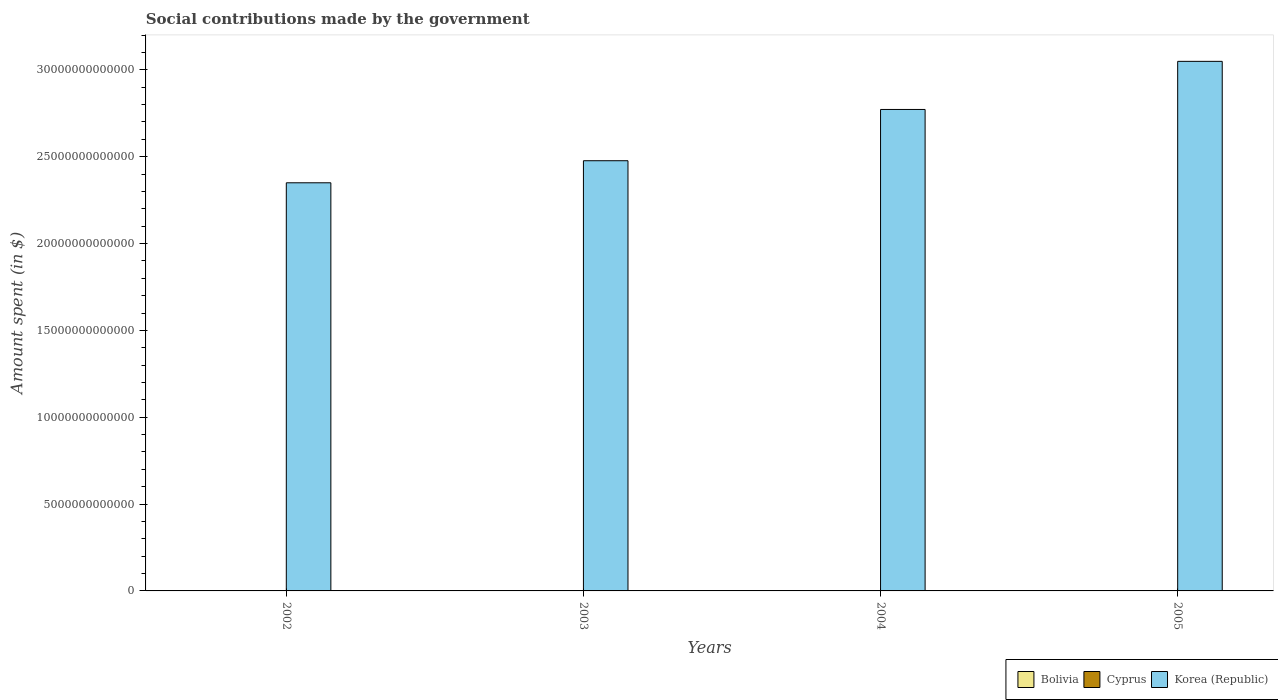How many different coloured bars are there?
Provide a short and direct response. 3. Are the number of bars per tick equal to the number of legend labels?
Keep it short and to the point. Yes. How many bars are there on the 4th tick from the right?
Your response must be concise. 3. What is the label of the 1st group of bars from the left?
Make the answer very short. 2002. What is the amount spent on social contributions in Cyprus in 2002?
Ensure brevity in your answer.  1.26e+09. Across all years, what is the maximum amount spent on social contributions in Bolivia?
Offer a terse response. 1.52e+09. Across all years, what is the minimum amount spent on social contributions in Cyprus?
Offer a terse response. 1.26e+09. In which year was the amount spent on social contributions in Cyprus maximum?
Ensure brevity in your answer.  2005. In which year was the amount spent on social contributions in Korea (Republic) minimum?
Provide a short and direct response. 2002. What is the total amount spent on social contributions in Cyprus in the graph?
Make the answer very short. 6.22e+09. What is the difference between the amount spent on social contributions in Korea (Republic) in 2002 and that in 2004?
Keep it short and to the point. -4.22e+12. What is the difference between the amount spent on social contributions in Cyprus in 2005 and the amount spent on social contributions in Korea (Republic) in 2002?
Give a very brief answer. -2.35e+13. What is the average amount spent on social contributions in Korea (Republic) per year?
Keep it short and to the point. 2.66e+13. In the year 2003, what is the difference between the amount spent on social contributions in Bolivia and amount spent on social contributions in Cyprus?
Your answer should be compact. 2.79e+07. In how many years, is the amount spent on social contributions in Cyprus greater than 10000000000000 $?
Ensure brevity in your answer.  0. What is the ratio of the amount spent on social contributions in Cyprus in 2002 to that in 2004?
Provide a short and direct response. 0.76. Is the difference between the amount spent on social contributions in Bolivia in 2002 and 2004 greater than the difference between the amount spent on social contributions in Cyprus in 2002 and 2004?
Offer a very short reply. Yes. What is the difference between the highest and the second highest amount spent on social contributions in Bolivia?
Give a very brief answer. 9.23e+07. What is the difference between the highest and the lowest amount spent on social contributions in Bolivia?
Ensure brevity in your answer.  4.39e+08. What does the 3rd bar from the left in 2005 represents?
Ensure brevity in your answer.  Korea (Republic). What does the 2nd bar from the right in 2002 represents?
Your answer should be very brief. Cyprus. How many bars are there?
Your answer should be compact. 12. Are all the bars in the graph horizontal?
Provide a succinct answer. No. How many years are there in the graph?
Offer a terse response. 4. What is the difference between two consecutive major ticks on the Y-axis?
Give a very brief answer. 5.00e+12. Are the values on the major ticks of Y-axis written in scientific E-notation?
Your answer should be very brief. No. Does the graph contain grids?
Offer a terse response. No. Where does the legend appear in the graph?
Give a very brief answer. Bottom right. How many legend labels are there?
Offer a very short reply. 3. How are the legend labels stacked?
Ensure brevity in your answer.  Horizontal. What is the title of the graph?
Your answer should be very brief. Social contributions made by the government. Does "Rwanda" appear as one of the legend labels in the graph?
Offer a terse response. No. What is the label or title of the Y-axis?
Ensure brevity in your answer.  Amount spent (in $). What is the Amount spent (in $) of Bolivia in 2002?
Provide a short and direct response. 1.08e+09. What is the Amount spent (in $) in Cyprus in 2002?
Offer a very short reply. 1.26e+09. What is the Amount spent (in $) of Korea (Republic) in 2002?
Offer a terse response. 2.35e+13. What is the Amount spent (in $) of Bolivia in 2003?
Offer a very short reply. 1.43e+09. What is the Amount spent (in $) in Cyprus in 2003?
Your answer should be very brief. 1.40e+09. What is the Amount spent (in $) of Korea (Republic) in 2003?
Provide a succinct answer. 2.48e+13. What is the Amount spent (in $) of Bolivia in 2004?
Your answer should be very brief. 1.34e+09. What is the Amount spent (in $) in Cyprus in 2004?
Provide a short and direct response. 1.66e+09. What is the Amount spent (in $) of Korea (Republic) in 2004?
Give a very brief answer. 2.77e+13. What is the Amount spent (in $) in Bolivia in 2005?
Offer a terse response. 1.52e+09. What is the Amount spent (in $) of Cyprus in 2005?
Your answer should be compact. 1.90e+09. What is the Amount spent (in $) in Korea (Republic) in 2005?
Your response must be concise. 3.05e+13. Across all years, what is the maximum Amount spent (in $) in Bolivia?
Ensure brevity in your answer.  1.52e+09. Across all years, what is the maximum Amount spent (in $) in Cyprus?
Provide a succinct answer. 1.90e+09. Across all years, what is the maximum Amount spent (in $) in Korea (Republic)?
Your answer should be very brief. 3.05e+13. Across all years, what is the minimum Amount spent (in $) of Bolivia?
Offer a terse response. 1.08e+09. Across all years, what is the minimum Amount spent (in $) of Cyprus?
Provide a succinct answer. 1.26e+09. Across all years, what is the minimum Amount spent (in $) of Korea (Republic)?
Your answer should be compact. 2.35e+13. What is the total Amount spent (in $) of Bolivia in the graph?
Provide a short and direct response. 5.38e+09. What is the total Amount spent (in $) of Cyprus in the graph?
Ensure brevity in your answer.  6.22e+09. What is the total Amount spent (in $) in Korea (Republic) in the graph?
Ensure brevity in your answer.  1.06e+14. What is the difference between the Amount spent (in $) in Bolivia in 2002 and that in 2003?
Make the answer very short. -3.46e+08. What is the difference between the Amount spent (in $) of Cyprus in 2002 and that in 2003?
Give a very brief answer. -1.46e+08. What is the difference between the Amount spent (in $) of Korea (Republic) in 2002 and that in 2003?
Your response must be concise. -1.27e+12. What is the difference between the Amount spent (in $) of Bolivia in 2002 and that in 2004?
Provide a succinct answer. -2.54e+08. What is the difference between the Amount spent (in $) in Cyprus in 2002 and that in 2004?
Offer a terse response. -4.04e+08. What is the difference between the Amount spent (in $) of Korea (Republic) in 2002 and that in 2004?
Ensure brevity in your answer.  -4.22e+12. What is the difference between the Amount spent (in $) in Bolivia in 2002 and that in 2005?
Keep it short and to the point. -4.39e+08. What is the difference between the Amount spent (in $) of Cyprus in 2002 and that in 2005?
Offer a terse response. -6.40e+08. What is the difference between the Amount spent (in $) of Korea (Republic) in 2002 and that in 2005?
Ensure brevity in your answer.  -6.99e+12. What is the difference between the Amount spent (in $) of Bolivia in 2003 and that in 2004?
Provide a succinct answer. 9.22e+07. What is the difference between the Amount spent (in $) in Cyprus in 2003 and that in 2004?
Provide a succinct answer. -2.59e+08. What is the difference between the Amount spent (in $) of Korea (Republic) in 2003 and that in 2004?
Provide a succinct answer. -2.95e+12. What is the difference between the Amount spent (in $) of Bolivia in 2003 and that in 2005?
Offer a very short reply. -9.23e+07. What is the difference between the Amount spent (in $) of Cyprus in 2003 and that in 2005?
Your answer should be compact. -4.95e+08. What is the difference between the Amount spent (in $) in Korea (Republic) in 2003 and that in 2005?
Your answer should be very brief. -5.72e+12. What is the difference between the Amount spent (in $) in Bolivia in 2004 and that in 2005?
Provide a short and direct response. -1.84e+08. What is the difference between the Amount spent (in $) of Cyprus in 2004 and that in 2005?
Your answer should be very brief. -2.36e+08. What is the difference between the Amount spent (in $) of Korea (Republic) in 2004 and that in 2005?
Give a very brief answer. -2.77e+12. What is the difference between the Amount spent (in $) in Bolivia in 2002 and the Amount spent (in $) in Cyprus in 2003?
Your answer should be compact. -3.18e+08. What is the difference between the Amount spent (in $) of Bolivia in 2002 and the Amount spent (in $) of Korea (Republic) in 2003?
Offer a terse response. -2.48e+13. What is the difference between the Amount spent (in $) in Cyprus in 2002 and the Amount spent (in $) in Korea (Republic) in 2003?
Ensure brevity in your answer.  -2.48e+13. What is the difference between the Amount spent (in $) of Bolivia in 2002 and the Amount spent (in $) of Cyprus in 2004?
Offer a terse response. -5.77e+08. What is the difference between the Amount spent (in $) in Bolivia in 2002 and the Amount spent (in $) in Korea (Republic) in 2004?
Give a very brief answer. -2.77e+13. What is the difference between the Amount spent (in $) of Cyprus in 2002 and the Amount spent (in $) of Korea (Republic) in 2004?
Offer a very short reply. -2.77e+13. What is the difference between the Amount spent (in $) in Bolivia in 2002 and the Amount spent (in $) in Cyprus in 2005?
Offer a very short reply. -8.13e+08. What is the difference between the Amount spent (in $) in Bolivia in 2002 and the Amount spent (in $) in Korea (Republic) in 2005?
Offer a very short reply. -3.05e+13. What is the difference between the Amount spent (in $) of Cyprus in 2002 and the Amount spent (in $) of Korea (Republic) in 2005?
Ensure brevity in your answer.  -3.05e+13. What is the difference between the Amount spent (in $) in Bolivia in 2003 and the Amount spent (in $) in Cyprus in 2004?
Your answer should be compact. -2.31e+08. What is the difference between the Amount spent (in $) of Bolivia in 2003 and the Amount spent (in $) of Korea (Republic) in 2004?
Your answer should be very brief. -2.77e+13. What is the difference between the Amount spent (in $) of Cyprus in 2003 and the Amount spent (in $) of Korea (Republic) in 2004?
Provide a short and direct response. -2.77e+13. What is the difference between the Amount spent (in $) in Bolivia in 2003 and the Amount spent (in $) in Cyprus in 2005?
Your answer should be very brief. -4.67e+08. What is the difference between the Amount spent (in $) in Bolivia in 2003 and the Amount spent (in $) in Korea (Republic) in 2005?
Your answer should be compact. -3.05e+13. What is the difference between the Amount spent (in $) in Cyprus in 2003 and the Amount spent (in $) in Korea (Republic) in 2005?
Offer a terse response. -3.05e+13. What is the difference between the Amount spent (in $) in Bolivia in 2004 and the Amount spent (in $) in Cyprus in 2005?
Ensure brevity in your answer.  -5.59e+08. What is the difference between the Amount spent (in $) of Bolivia in 2004 and the Amount spent (in $) of Korea (Republic) in 2005?
Provide a short and direct response. -3.05e+13. What is the difference between the Amount spent (in $) of Cyprus in 2004 and the Amount spent (in $) of Korea (Republic) in 2005?
Make the answer very short. -3.05e+13. What is the average Amount spent (in $) in Bolivia per year?
Ensure brevity in your answer.  1.34e+09. What is the average Amount spent (in $) in Cyprus per year?
Ensure brevity in your answer.  1.55e+09. What is the average Amount spent (in $) of Korea (Republic) per year?
Provide a short and direct response. 2.66e+13. In the year 2002, what is the difference between the Amount spent (in $) in Bolivia and Amount spent (in $) in Cyprus?
Provide a succinct answer. -1.73e+08. In the year 2002, what is the difference between the Amount spent (in $) in Bolivia and Amount spent (in $) in Korea (Republic)?
Keep it short and to the point. -2.35e+13. In the year 2002, what is the difference between the Amount spent (in $) of Cyprus and Amount spent (in $) of Korea (Republic)?
Provide a short and direct response. -2.35e+13. In the year 2003, what is the difference between the Amount spent (in $) of Bolivia and Amount spent (in $) of Cyprus?
Offer a very short reply. 2.79e+07. In the year 2003, what is the difference between the Amount spent (in $) of Bolivia and Amount spent (in $) of Korea (Republic)?
Your answer should be very brief. -2.48e+13. In the year 2003, what is the difference between the Amount spent (in $) in Cyprus and Amount spent (in $) in Korea (Republic)?
Ensure brevity in your answer.  -2.48e+13. In the year 2004, what is the difference between the Amount spent (in $) of Bolivia and Amount spent (in $) of Cyprus?
Your response must be concise. -3.23e+08. In the year 2004, what is the difference between the Amount spent (in $) in Bolivia and Amount spent (in $) in Korea (Republic)?
Provide a succinct answer. -2.77e+13. In the year 2004, what is the difference between the Amount spent (in $) in Cyprus and Amount spent (in $) in Korea (Republic)?
Keep it short and to the point. -2.77e+13. In the year 2005, what is the difference between the Amount spent (in $) in Bolivia and Amount spent (in $) in Cyprus?
Offer a terse response. -3.75e+08. In the year 2005, what is the difference between the Amount spent (in $) in Bolivia and Amount spent (in $) in Korea (Republic)?
Offer a terse response. -3.05e+13. In the year 2005, what is the difference between the Amount spent (in $) in Cyprus and Amount spent (in $) in Korea (Republic)?
Make the answer very short. -3.05e+13. What is the ratio of the Amount spent (in $) in Bolivia in 2002 to that in 2003?
Offer a very short reply. 0.76. What is the ratio of the Amount spent (in $) of Cyprus in 2002 to that in 2003?
Offer a very short reply. 0.9. What is the ratio of the Amount spent (in $) in Korea (Republic) in 2002 to that in 2003?
Your answer should be very brief. 0.95. What is the ratio of the Amount spent (in $) in Bolivia in 2002 to that in 2004?
Provide a short and direct response. 0.81. What is the ratio of the Amount spent (in $) of Cyprus in 2002 to that in 2004?
Provide a succinct answer. 0.76. What is the ratio of the Amount spent (in $) of Korea (Republic) in 2002 to that in 2004?
Your answer should be very brief. 0.85. What is the ratio of the Amount spent (in $) in Bolivia in 2002 to that in 2005?
Provide a short and direct response. 0.71. What is the ratio of the Amount spent (in $) in Cyprus in 2002 to that in 2005?
Provide a short and direct response. 0.66. What is the ratio of the Amount spent (in $) in Korea (Republic) in 2002 to that in 2005?
Make the answer very short. 0.77. What is the ratio of the Amount spent (in $) of Bolivia in 2003 to that in 2004?
Offer a terse response. 1.07. What is the ratio of the Amount spent (in $) of Cyprus in 2003 to that in 2004?
Your response must be concise. 0.84. What is the ratio of the Amount spent (in $) of Korea (Republic) in 2003 to that in 2004?
Offer a terse response. 0.89. What is the ratio of the Amount spent (in $) of Bolivia in 2003 to that in 2005?
Your response must be concise. 0.94. What is the ratio of the Amount spent (in $) of Cyprus in 2003 to that in 2005?
Your answer should be compact. 0.74. What is the ratio of the Amount spent (in $) of Korea (Republic) in 2003 to that in 2005?
Offer a very short reply. 0.81. What is the ratio of the Amount spent (in $) of Bolivia in 2004 to that in 2005?
Make the answer very short. 0.88. What is the ratio of the Amount spent (in $) in Cyprus in 2004 to that in 2005?
Make the answer very short. 0.88. What is the ratio of the Amount spent (in $) of Korea (Republic) in 2004 to that in 2005?
Make the answer very short. 0.91. What is the difference between the highest and the second highest Amount spent (in $) in Bolivia?
Make the answer very short. 9.23e+07. What is the difference between the highest and the second highest Amount spent (in $) in Cyprus?
Give a very brief answer. 2.36e+08. What is the difference between the highest and the second highest Amount spent (in $) in Korea (Republic)?
Provide a succinct answer. 2.77e+12. What is the difference between the highest and the lowest Amount spent (in $) of Bolivia?
Your answer should be very brief. 4.39e+08. What is the difference between the highest and the lowest Amount spent (in $) in Cyprus?
Make the answer very short. 6.40e+08. What is the difference between the highest and the lowest Amount spent (in $) of Korea (Republic)?
Give a very brief answer. 6.99e+12. 